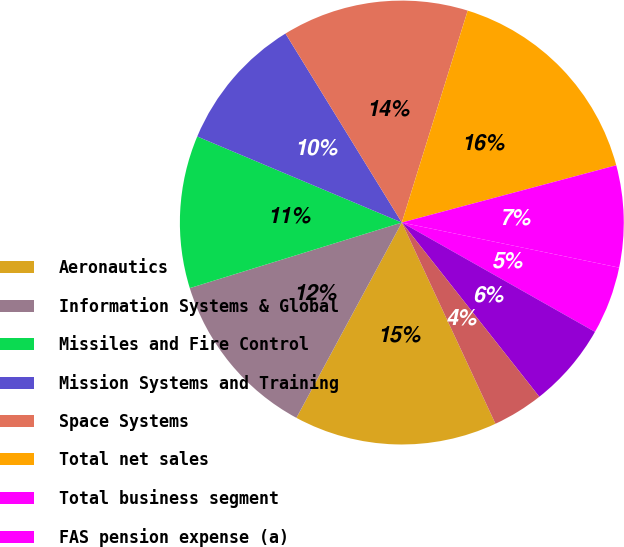Convert chart. <chart><loc_0><loc_0><loc_500><loc_500><pie_chart><fcel>Aeronautics<fcel>Information Systems & Global<fcel>Missiles and Fire Control<fcel>Mission Systems and Training<fcel>Space Systems<fcel>Total net sales<fcel>Total business segment<fcel>FAS pension expense (a)<fcel>Less CAS pension cost (b)<fcel>FAS/CAS pension income<nl><fcel>14.81%<fcel>12.35%<fcel>11.11%<fcel>9.88%<fcel>13.58%<fcel>16.05%<fcel>7.41%<fcel>4.94%<fcel>6.17%<fcel>3.7%<nl></chart> 